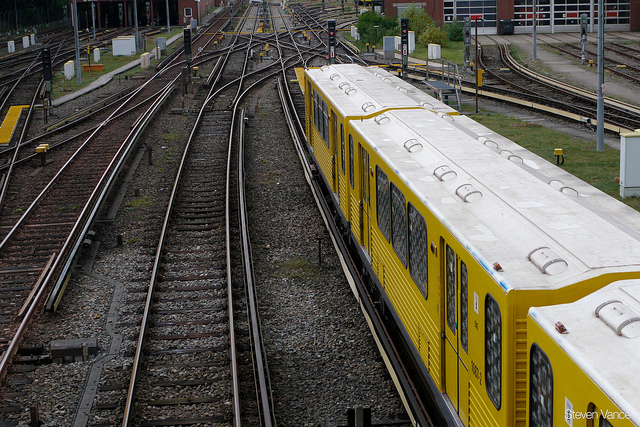Please identify all text content in this image. Vavce Steven 